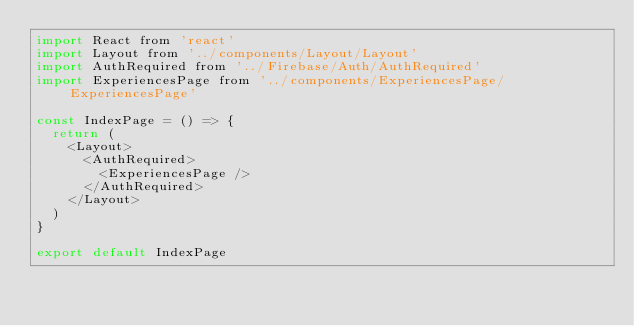Convert code to text. <code><loc_0><loc_0><loc_500><loc_500><_JavaScript_>import React from 'react'
import Layout from '../components/Layout/Layout'
import AuthRequired from '../Firebase/Auth/AuthRequired'
import ExperiencesPage from '../components/ExperiencesPage/ExperiencesPage'

const IndexPage = () => {
  return (
    <Layout>
      <AuthRequired>
        <ExperiencesPage />
      </AuthRequired>
    </Layout>
  )
}

export default IndexPage
</code> 